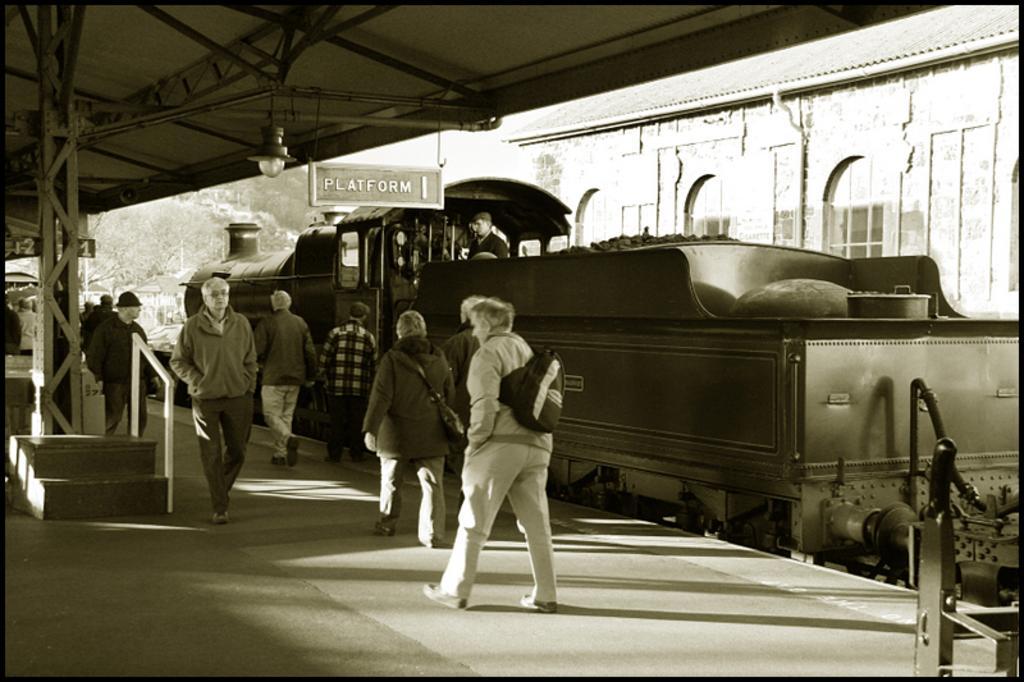Describe this image in one or two sentences. This is a black and white image. In the center of the image we can see persons walking on the platform. In the background we can see train on the railway track, building, trees and sky. 